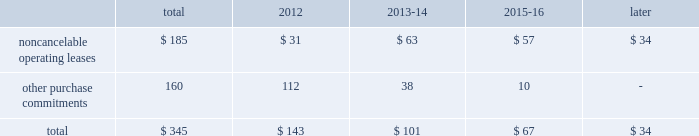2322 t .
R o w e p r i c e g r o u p a n n u a l r e p o r t 2 0 1 1 c o n t r a c t u a l o b l i g at i o n s the table presents a summary of our future obligations ( in a0millions ) under the terms of existing operating leases and other contractual cash purchase commitments at december 31 , 2011 .
Other purchase commitments include contractual amounts that will be due for the purchase of goods or services to be used in our operations and may be cancelable at earlier times than those indicated , under certain conditions that may involve termination fees .
Because these obligations are generally of a normal recurring nature , we expect that we will fund them from future cash flows from operations .
The information presented does not include operating expenses or capital expenditures that will be committed in the normal course of operations in 2012 and future years .
The information also excludes the $ 4.7 a0million of uncertain tax positions discussed in note 9 to our consolidated financial statements because it is not possible to estimate the time period in which a payment might be made to the tax authorities. .
We also have outstanding commitments to fund additional contributions to investment partnerships in which we have an existing investment totaling $ 42.5 a0million at december 31 , 2011 .
C r i t i c a l a c c o u n t i n g p o l i c i e s the preparation of financial statements often requires the selection of specific accounting methods and policies from among several acceptable alternatives .
Further , significant estimates and judgments may be required in selecting and applying those methods and policies in the recognition of the assets and liabilities in our balance sheet , the revenues and expenses in our statement of income , and the information that is contained in our significant accounting policies and notes to consolidated financial statements .
Making these estimates and judgments requires the analysis of information concerning events that may not yet be complete and of facts and circumstances that may change over time .
Accordingly , actual amounts or future results can differ materially from those estimates that we include currently in our consolidated financial statements , significant accounting policies , and notes .
We present those significant accounting policies used in the preparation of our consolidated financial statements as an integral part of those statements within this 2011 annual report .
In the following discussion , we highlight and explain further certain of those policies that are most critical to the preparation and understanding of our financial statements .
Other than temporary impairments of available-for-sale securities .
We generally classify our investment holdings in sponsored mutual funds and the debt securities held for investment by our savings bank subsidiary as available-for-sale .
At the end of each quarter , we mark the carrying amount of each investment holding to fair value and recognize an unrealized gain or loss as a component of comprehensive income within the statement of stockholders 2019 equity .
We next review each individual security position that has an unrealized loss or impairment to determine if that impairment is other than temporary .
In determining whether a mutual fund holding is other than temporarily impaired , we consider many factors , including the duration of time it has existed , the severity of the impairment , any subsequent changes in value , and our intent and ability to hold the security for a period of time sufficient for an anticipated recovery in fair value .
Subject to the other considerations noted above , with respect to duration of time , we believe a mutual fund holding with an unrealized loss that has persisted daily throughout the six months between quarter-ends is generally presumed to have an other than temporary impairment .
We may also recognize an other than temporary loss of less than six months in our statement of income if the particular circumstances of the underlying investment do not warrant our belief that a near-term recovery is possible .
An impaired debt security held by our savings bank subsidiary is considered to have an other than temporary loss that we will recognize in our statement of income if the impairment is caused by a change in credit quality that affects our ability to recover our amortized cost or if we intend to sell the security or believe that it is more likely than not that we will be required to sell the security before recovering cost .
Minor impairments of 5% ( 5 % ) or less are generally considered temporary .
Other than temporary impairments of equity method investments .
We evaluate our equity method investments , including our investment in uti , for impairment when events or changes in circumstances indicate that the carrying value of the investment exceeds its fair value , and the decline in fair value is other than temporary .
Goodwill .
We internally conduct , manage and report our operations as one investment advisory business .
We do not have distinct operating segments or components that separately constitute a business .
Accordingly , we attribute goodwill to a single reportable business segment and reporting unit 2014our investment advisory business .
We evaluate the carrying amount of goodwill in our balance sheet for possible impairment on an annual basis in the third quarter of each year using a fair value approach .
Goodwill would be considered impaired whenever our historical carrying amount exceeds the fair value of our investment advisory business .
Our annual testing has demonstrated that the fair value of our investment advisory business ( our market capitalization ) exceeds our carrying amount ( our stockholders 2019 equity ) and , therefore , no impairment exists .
Should we reach a different conclusion in the future , additional work would be performed to ascertain the amount of the non-cash impairment charge to be recognized .
We must also perform impairment testing at other times if an event or circumstance occurs indicating that it is more likely than not that an impairment has been incurred .
The maximum future impairment of goodwill that we could incur is the amount recognized in our balance sheet , $ 665.7 a0million .
Stock options .
We recognize stock option-based compensation expense in our consolidated statement of income using a fair value based method .
Fair value methods use a valuation model for shorter-term , market-traded financial instruments to theoretically value stock option grants even though they are not available for trading and are of longer duration .
The black- scholes option-pricing model that we use includes the input of certain variables that are dependent on future expectations , including the expected lives of our options from grant date to exercise date , the volatility of our underlying common shares in the market over that time period , and the rate of dividends that we will pay during that time .
Our estimates of these variables are made for the purpose of using the valuation model to determine an expense for each reporting period and are not subsequently adjusted .
Unlike most of our expenses , the resulting charge to earnings using a fair value based method is a non-cash charge that is never measured by , or adjusted based on , a cash outflow .
Provision for income taxes .
After compensation and related costs , our provision for income taxes on our earnings is our largest annual expense .
We operate in numerous states and countries through our various subsidiaries , and must allocate our income , expenses , and earnings under the various laws and regulations of each of these taxing jurisdictions .
Accordingly , our provision for income taxes represents our total estimate of the liability that we have incurred in doing business each year in all of our locations .
Annually , we file tax returns that represent our filing positions with each jurisdiction and settle our return liabilities .
Each jurisdiction has the right to audit those returns and may take different positions with respect to income and expense allocations and taxable earnings determinations .
From time to time , we may also provide for estimated liabilities associated with uncertain tax return filing positions that are subject to , or in the process of , being audited by various tax authorities .
Because the determination of our annual provision is subject to judgments and estimates , it is likely that actual results will vary from those recognized in our financial statements .
As a result , we recognize additions to , or reductions of , income tax expense during a reporting period that pertain to prior period provisions as our estimated liabilities are revised and actual tax returns and tax audits are settled .
We recognize any such prior period adjustment in the discrete quarterly period in which it is determined .
N e w ly i s s u e d b u t n o t y e t a d o p t e d a c c o u n t i n g g u i d a n c e in may 2011 , the fasb issued amended guidance clarifying how to measure and disclose fair value .
We do not believe the adoption of such amended guidance on january 1 , 2012 , will have a significant effect on our consolidated financial statements .
We have also considered all other newly issued accounting guidance that is applicable to our operations and the preparation of our consolidated statements , including that which we have not yet adopted .
We do not believe that any such guidance will have a material effect on our financial position or results of operation. .
What percent of the total amount is made up of noncancelable operating leases? 
Computations: (185 / 345)
Answer: 0.53623. 2322 t .
R o w e p r i c e g r o u p a n n u a l r e p o r t 2 0 1 1 c o n t r a c t u a l o b l i g at i o n s the table presents a summary of our future obligations ( in a0millions ) under the terms of existing operating leases and other contractual cash purchase commitments at december 31 , 2011 .
Other purchase commitments include contractual amounts that will be due for the purchase of goods or services to be used in our operations and may be cancelable at earlier times than those indicated , under certain conditions that may involve termination fees .
Because these obligations are generally of a normal recurring nature , we expect that we will fund them from future cash flows from operations .
The information presented does not include operating expenses or capital expenditures that will be committed in the normal course of operations in 2012 and future years .
The information also excludes the $ 4.7 a0million of uncertain tax positions discussed in note 9 to our consolidated financial statements because it is not possible to estimate the time period in which a payment might be made to the tax authorities. .
We also have outstanding commitments to fund additional contributions to investment partnerships in which we have an existing investment totaling $ 42.5 a0million at december 31 , 2011 .
C r i t i c a l a c c o u n t i n g p o l i c i e s the preparation of financial statements often requires the selection of specific accounting methods and policies from among several acceptable alternatives .
Further , significant estimates and judgments may be required in selecting and applying those methods and policies in the recognition of the assets and liabilities in our balance sheet , the revenues and expenses in our statement of income , and the information that is contained in our significant accounting policies and notes to consolidated financial statements .
Making these estimates and judgments requires the analysis of information concerning events that may not yet be complete and of facts and circumstances that may change over time .
Accordingly , actual amounts or future results can differ materially from those estimates that we include currently in our consolidated financial statements , significant accounting policies , and notes .
We present those significant accounting policies used in the preparation of our consolidated financial statements as an integral part of those statements within this 2011 annual report .
In the following discussion , we highlight and explain further certain of those policies that are most critical to the preparation and understanding of our financial statements .
Other than temporary impairments of available-for-sale securities .
We generally classify our investment holdings in sponsored mutual funds and the debt securities held for investment by our savings bank subsidiary as available-for-sale .
At the end of each quarter , we mark the carrying amount of each investment holding to fair value and recognize an unrealized gain or loss as a component of comprehensive income within the statement of stockholders 2019 equity .
We next review each individual security position that has an unrealized loss or impairment to determine if that impairment is other than temporary .
In determining whether a mutual fund holding is other than temporarily impaired , we consider many factors , including the duration of time it has existed , the severity of the impairment , any subsequent changes in value , and our intent and ability to hold the security for a period of time sufficient for an anticipated recovery in fair value .
Subject to the other considerations noted above , with respect to duration of time , we believe a mutual fund holding with an unrealized loss that has persisted daily throughout the six months between quarter-ends is generally presumed to have an other than temporary impairment .
We may also recognize an other than temporary loss of less than six months in our statement of income if the particular circumstances of the underlying investment do not warrant our belief that a near-term recovery is possible .
An impaired debt security held by our savings bank subsidiary is considered to have an other than temporary loss that we will recognize in our statement of income if the impairment is caused by a change in credit quality that affects our ability to recover our amortized cost or if we intend to sell the security or believe that it is more likely than not that we will be required to sell the security before recovering cost .
Minor impairments of 5% ( 5 % ) or less are generally considered temporary .
Other than temporary impairments of equity method investments .
We evaluate our equity method investments , including our investment in uti , for impairment when events or changes in circumstances indicate that the carrying value of the investment exceeds its fair value , and the decline in fair value is other than temporary .
Goodwill .
We internally conduct , manage and report our operations as one investment advisory business .
We do not have distinct operating segments or components that separately constitute a business .
Accordingly , we attribute goodwill to a single reportable business segment and reporting unit 2014our investment advisory business .
We evaluate the carrying amount of goodwill in our balance sheet for possible impairment on an annual basis in the third quarter of each year using a fair value approach .
Goodwill would be considered impaired whenever our historical carrying amount exceeds the fair value of our investment advisory business .
Our annual testing has demonstrated that the fair value of our investment advisory business ( our market capitalization ) exceeds our carrying amount ( our stockholders 2019 equity ) and , therefore , no impairment exists .
Should we reach a different conclusion in the future , additional work would be performed to ascertain the amount of the non-cash impairment charge to be recognized .
We must also perform impairment testing at other times if an event or circumstance occurs indicating that it is more likely than not that an impairment has been incurred .
The maximum future impairment of goodwill that we could incur is the amount recognized in our balance sheet , $ 665.7 a0million .
Stock options .
We recognize stock option-based compensation expense in our consolidated statement of income using a fair value based method .
Fair value methods use a valuation model for shorter-term , market-traded financial instruments to theoretically value stock option grants even though they are not available for trading and are of longer duration .
The black- scholes option-pricing model that we use includes the input of certain variables that are dependent on future expectations , including the expected lives of our options from grant date to exercise date , the volatility of our underlying common shares in the market over that time period , and the rate of dividends that we will pay during that time .
Our estimates of these variables are made for the purpose of using the valuation model to determine an expense for each reporting period and are not subsequently adjusted .
Unlike most of our expenses , the resulting charge to earnings using a fair value based method is a non-cash charge that is never measured by , or adjusted based on , a cash outflow .
Provision for income taxes .
After compensation and related costs , our provision for income taxes on our earnings is our largest annual expense .
We operate in numerous states and countries through our various subsidiaries , and must allocate our income , expenses , and earnings under the various laws and regulations of each of these taxing jurisdictions .
Accordingly , our provision for income taxes represents our total estimate of the liability that we have incurred in doing business each year in all of our locations .
Annually , we file tax returns that represent our filing positions with each jurisdiction and settle our return liabilities .
Each jurisdiction has the right to audit those returns and may take different positions with respect to income and expense allocations and taxable earnings determinations .
From time to time , we may also provide for estimated liabilities associated with uncertain tax return filing positions that are subject to , or in the process of , being audited by various tax authorities .
Because the determination of our annual provision is subject to judgments and estimates , it is likely that actual results will vary from those recognized in our financial statements .
As a result , we recognize additions to , or reductions of , income tax expense during a reporting period that pertain to prior period provisions as our estimated liabilities are revised and actual tax returns and tax audits are settled .
We recognize any such prior period adjustment in the discrete quarterly period in which it is determined .
N e w ly i s s u e d b u t n o t y e t a d o p t e d a c c o u n t i n g g u i d a n c e in may 2011 , the fasb issued amended guidance clarifying how to measure and disclose fair value .
We do not believe the adoption of such amended guidance on january 1 , 2012 , will have a significant effect on our consolidated financial statements .
We have also considered all other newly issued accounting guidance that is applicable to our operations and the preparation of our consolidated statements , including that which we have not yet adopted .
We do not believe that any such guidance will have a material effect on our financial position or results of operation. .
What is the percent change in other purchase commitments between 2013-14 and 2015-16? 
Computations: ((10 * 38) / 38)
Answer: 10.0. 